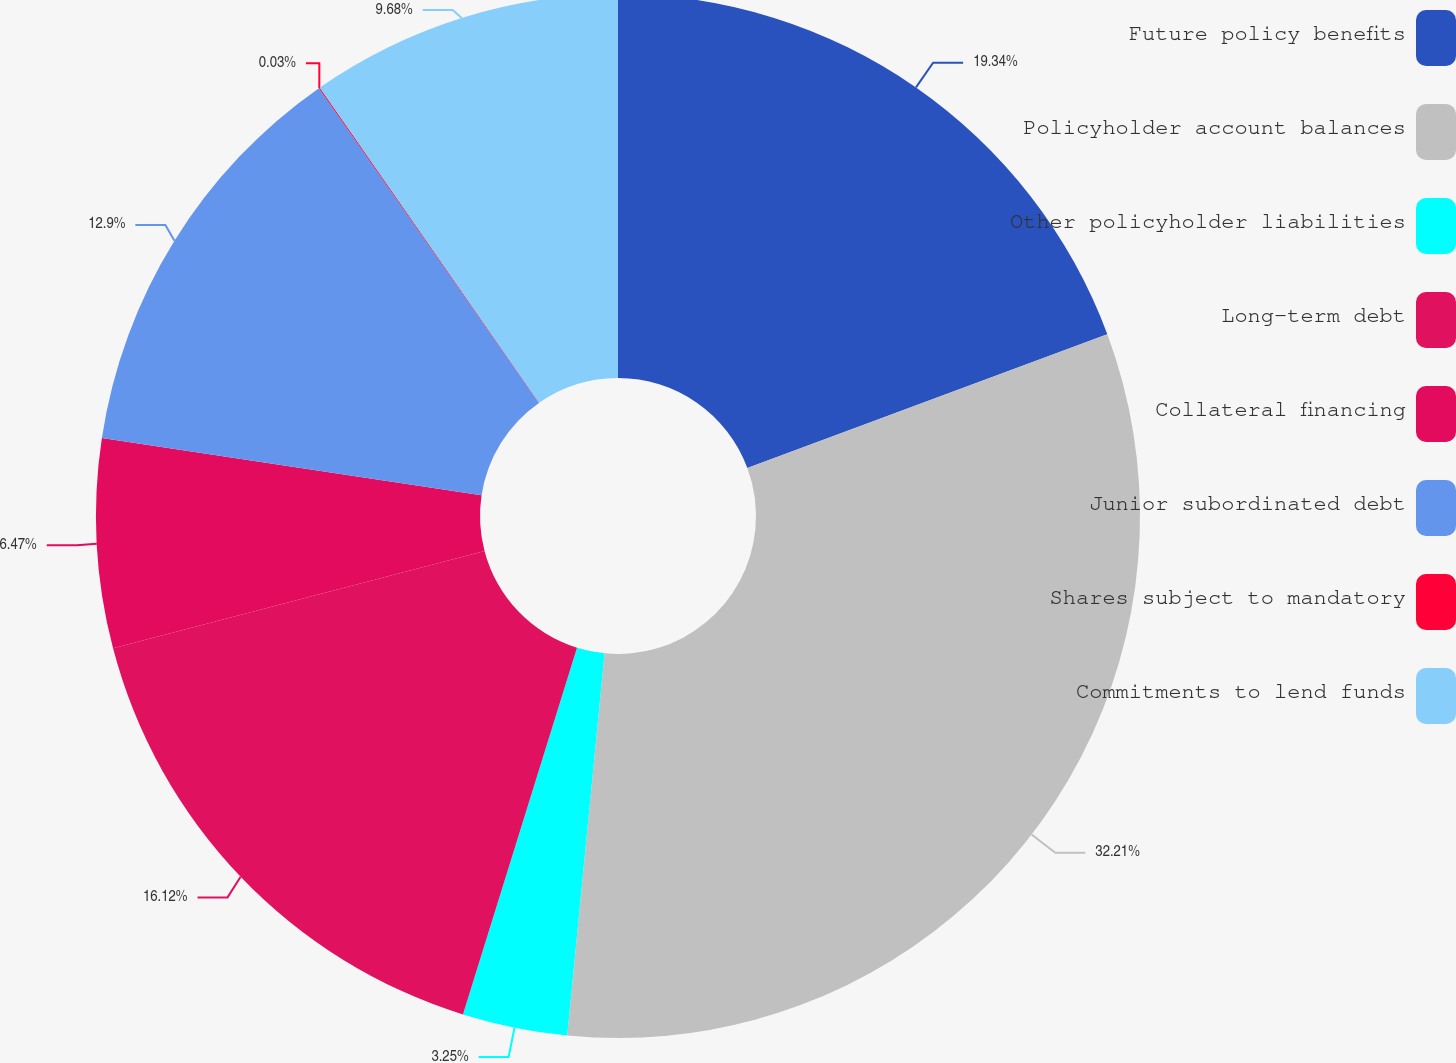Convert chart to OTSL. <chart><loc_0><loc_0><loc_500><loc_500><pie_chart><fcel>Future policy benefits<fcel>Policyholder account balances<fcel>Other policyholder liabilities<fcel>Long-term debt<fcel>Collateral financing<fcel>Junior subordinated debt<fcel>Shares subject to mandatory<fcel>Commitments to lend funds<nl><fcel>19.34%<fcel>32.21%<fcel>3.25%<fcel>16.12%<fcel>6.47%<fcel>12.9%<fcel>0.03%<fcel>9.68%<nl></chart> 